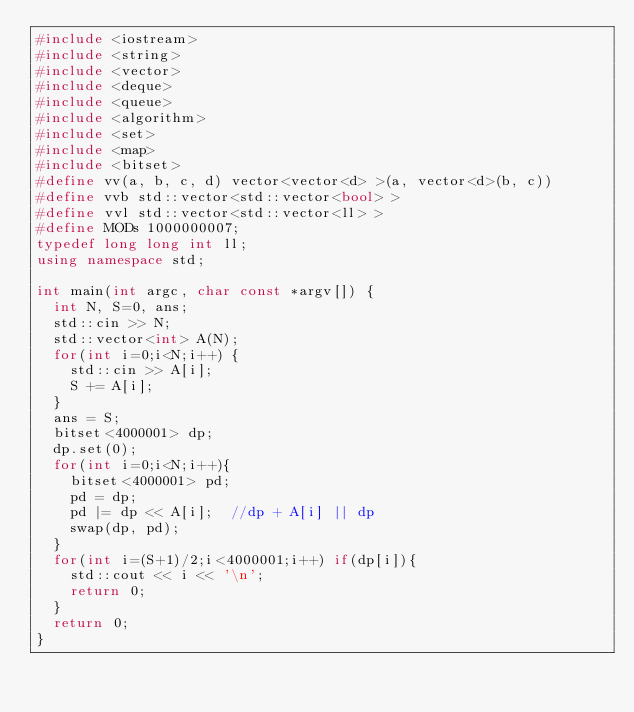Convert code to text. <code><loc_0><loc_0><loc_500><loc_500><_C++_>#include <iostream>
#include <string>
#include <vector>
#include <deque>
#include <queue>
#include <algorithm>
#include <set>
#include <map>
#include <bitset>
#define vv(a, b, c, d) vector<vector<d> >(a, vector<d>(b, c))
#define vvb std::vector<std::vector<bool> >
#define vvl std::vector<std::vector<ll> >
#define MODs 1000000007;
typedef long long int ll;
using namespace std;

int main(int argc, char const *argv[]) {
  int N, S=0, ans;
  std::cin >> N;
  std::vector<int> A(N);
  for(int i=0;i<N;i++) {
    std::cin >> A[i];
    S += A[i];
  }
  ans = S;
  bitset<4000001> dp;
  dp.set(0);
  for(int i=0;i<N;i++){
    bitset<4000001> pd;
    pd = dp;
    pd |= dp << A[i];  //dp + A[i] || dp
    swap(dp, pd);
  }
  for(int i=(S+1)/2;i<4000001;i++) if(dp[i]){
    std::cout << i << '\n';
    return 0;
  }
  return 0;
}
</code> 